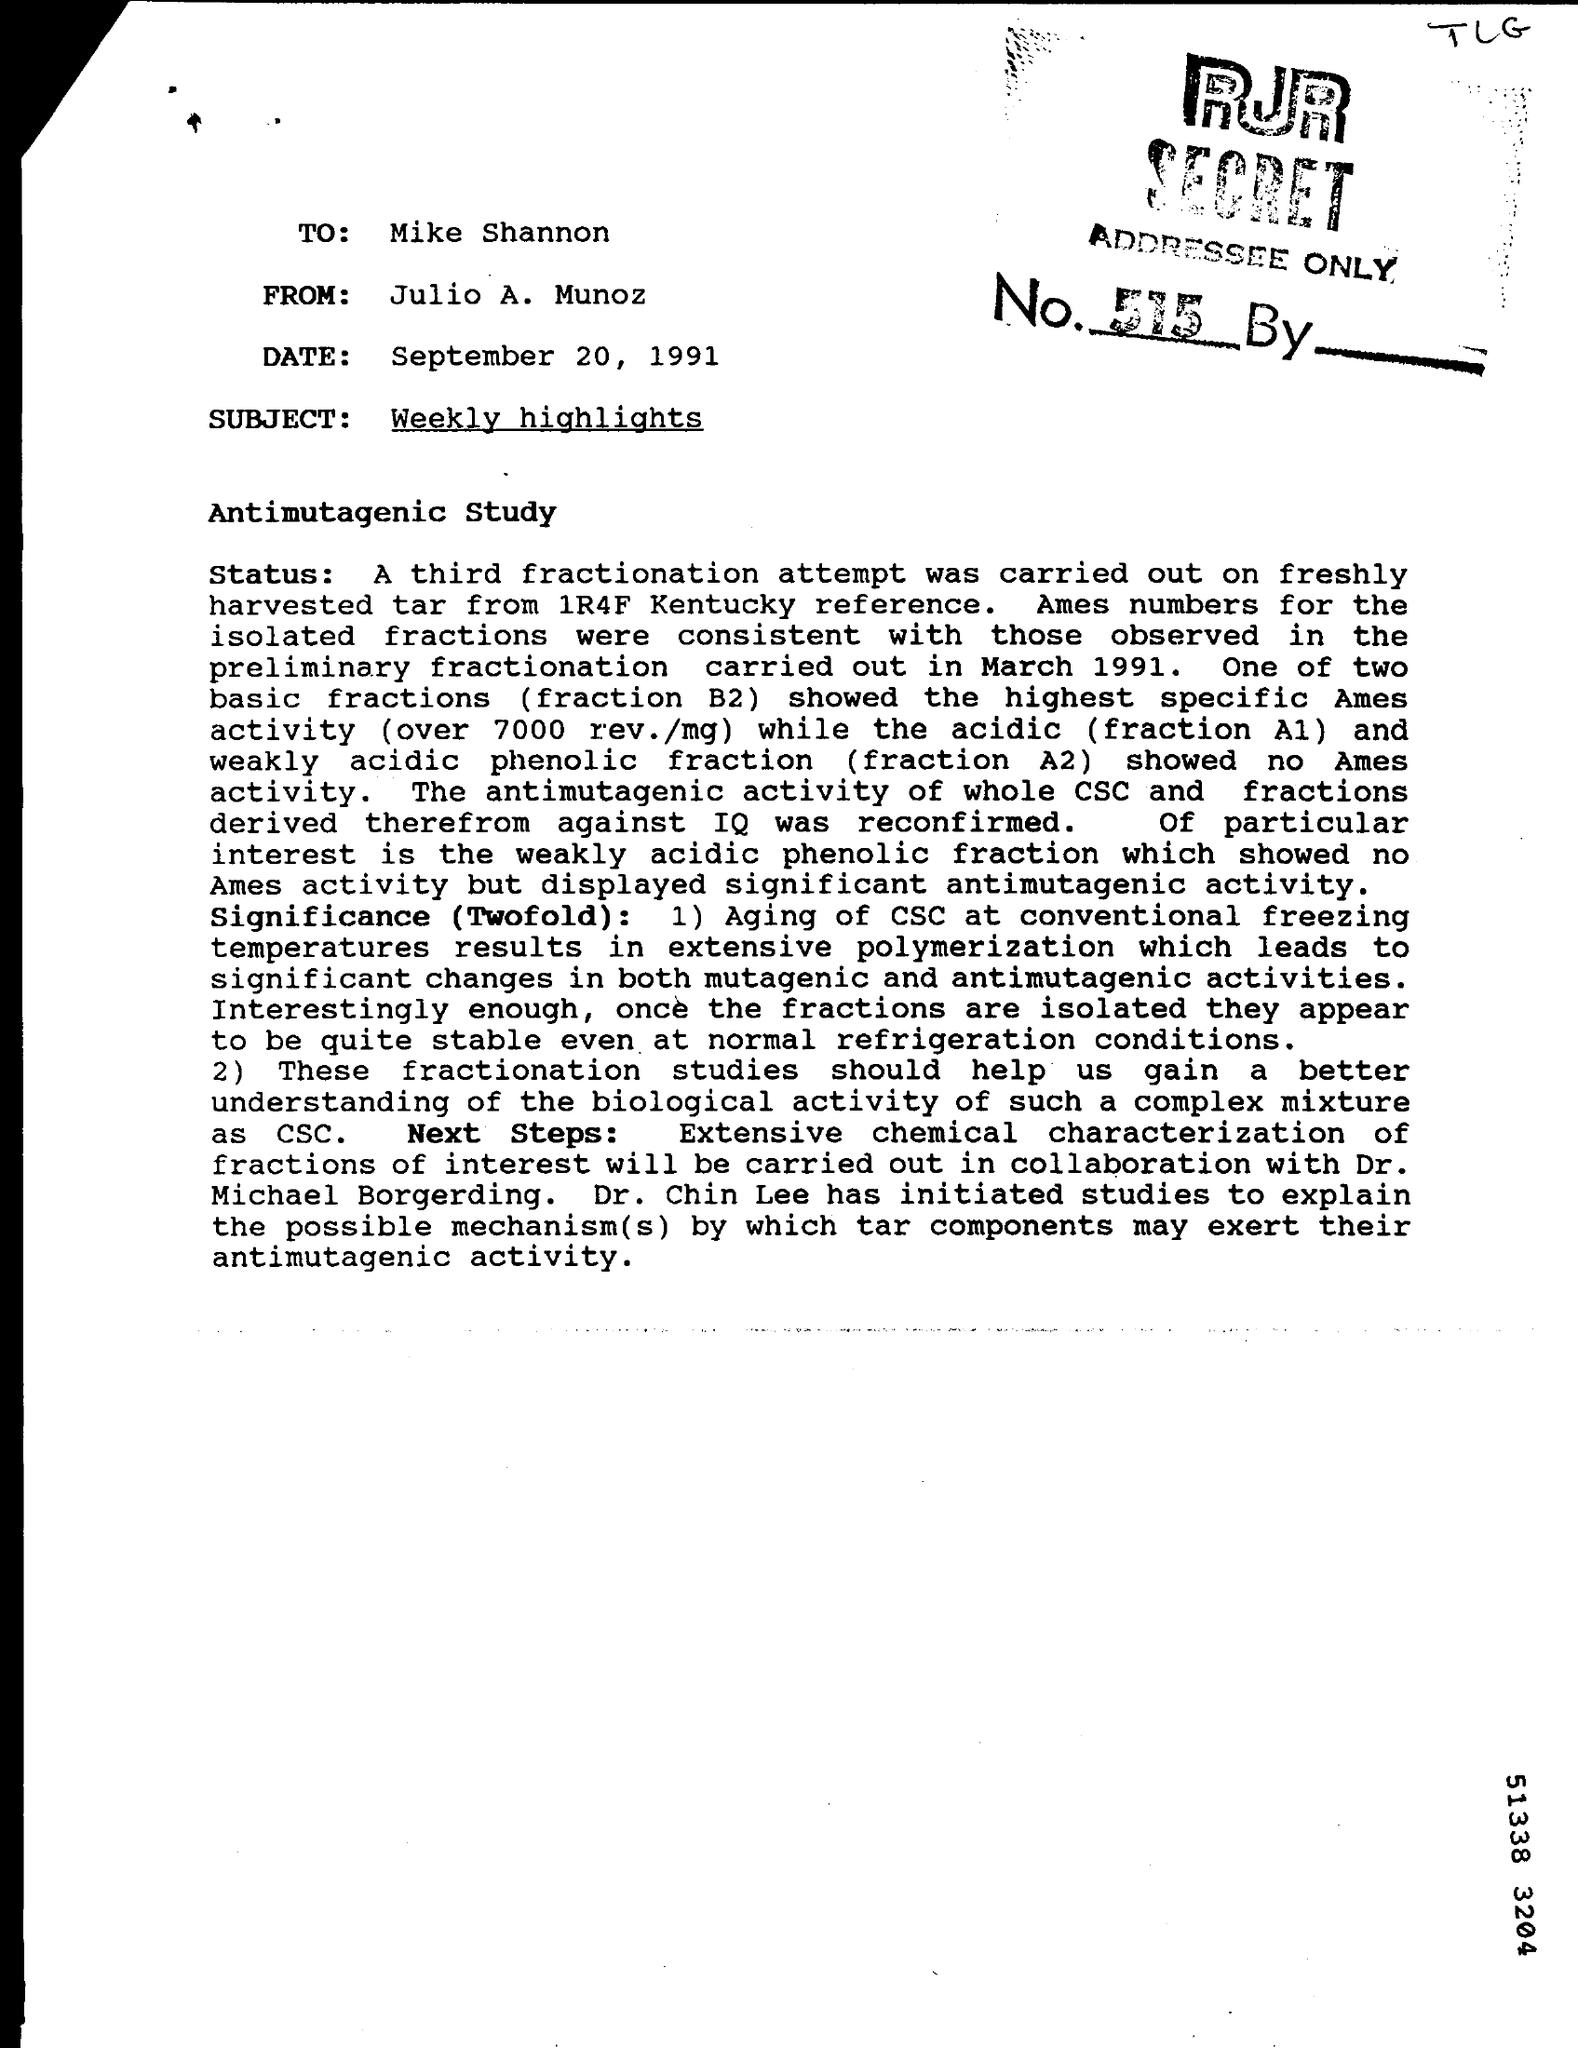Specify some key components in this picture. The person who wrote this letter is Julio A. Munoz. The date mentioned in the letter is September 20, 1991. The subject mentioned in the given letter is "weekly highlights. The letter was written to Mike Shannon. 